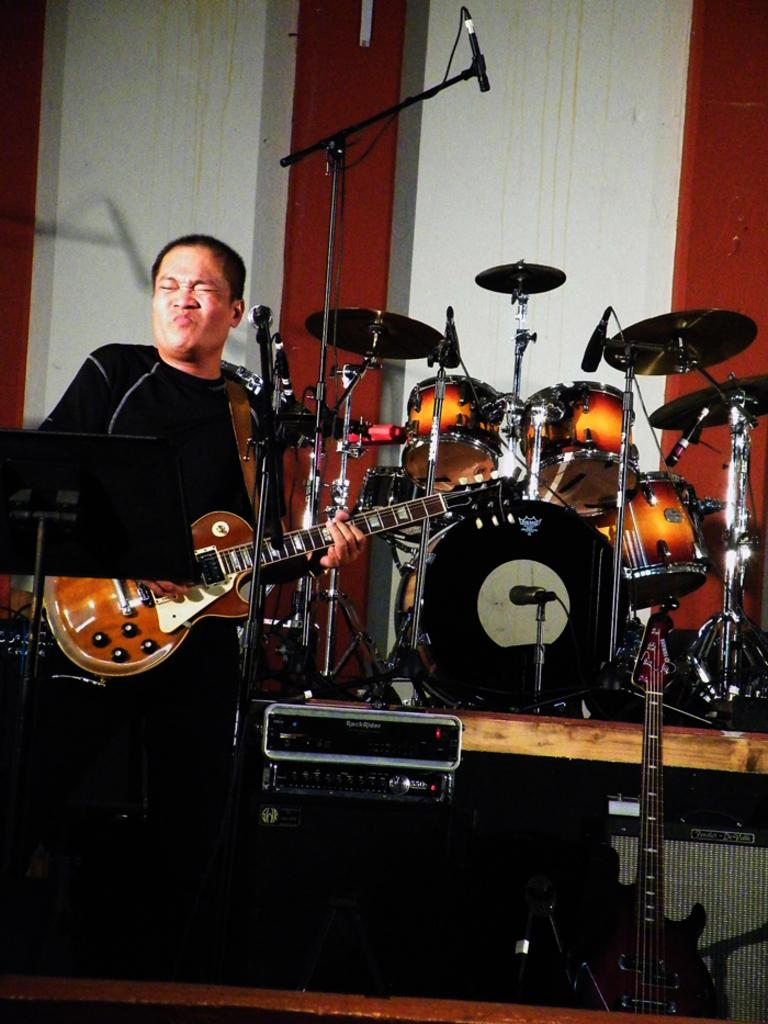What is the man in the image doing? The man is playing a guitar. What is in front of the man? There is a microphone in front of the man. What else can be seen near the man? There are musical instruments near the man. What can be seen in the background of the image? There is a wall in the background. Can you tell me how many buckets are visible in the image? There are no buckets present in the image. What type of kitten is sitting on the man's lap in the image? There is no kitten present in the image. 